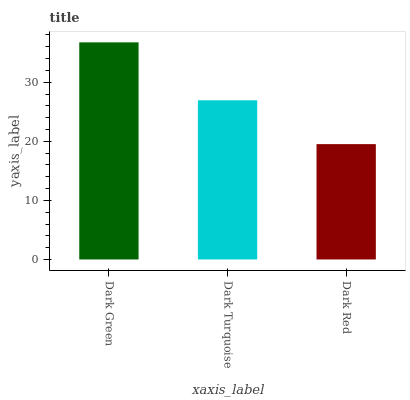Is Dark Red the minimum?
Answer yes or no. Yes. Is Dark Green the maximum?
Answer yes or no. Yes. Is Dark Turquoise the minimum?
Answer yes or no. No. Is Dark Turquoise the maximum?
Answer yes or no. No. Is Dark Green greater than Dark Turquoise?
Answer yes or no. Yes. Is Dark Turquoise less than Dark Green?
Answer yes or no. Yes. Is Dark Turquoise greater than Dark Green?
Answer yes or no. No. Is Dark Green less than Dark Turquoise?
Answer yes or no. No. Is Dark Turquoise the high median?
Answer yes or no. Yes. Is Dark Turquoise the low median?
Answer yes or no. Yes. Is Dark Green the high median?
Answer yes or no. No. Is Dark Green the low median?
Answer yes or no. No. 